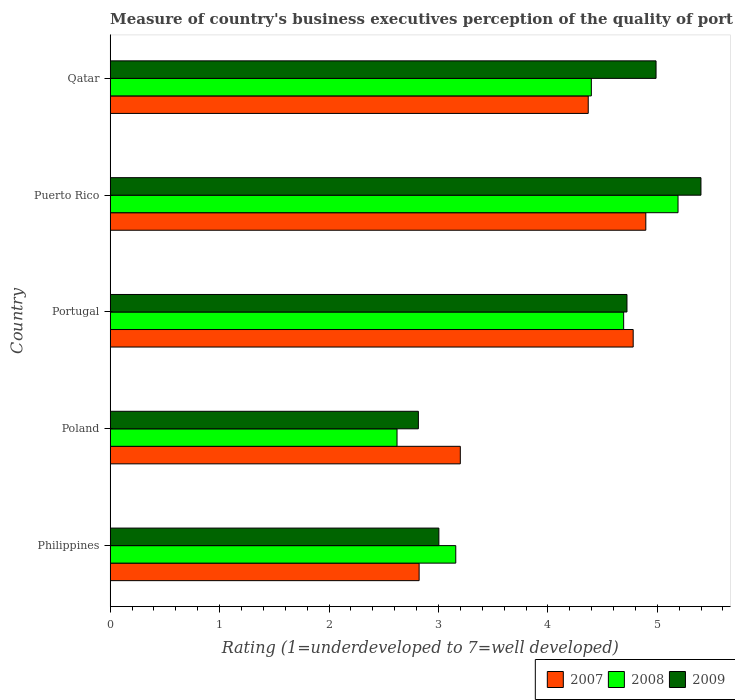How many groups of bars are there?
Your answer should be very brief. 5. How many bars are there on the 5th tick from the bottom?
Keep it short and to the point. 3. In how many cases, is the number of bars for a given country not equal to the number of legend labels?
Make the answer very short. 0. What is the ratings of the quality of port infrastructure in 2007 in Portugal?
Offer a terse response. 4.78. Across all countries, what is the maximum ratings of the quality of port infrastructure in 2007?
Provide a succinct answer. 4.89. Across all countries, what is the minimum ratings of the quality of port infrastructure in 2008?
Make the answer very short. 2.62. In which country was the ratings of the quality of port infrastructure in 2008 maximum?
Your answer should be compact. Puerto Rico. In which country was the ratings of the quality of port infrastructure in 2007 minimum?
Provide a succinct answer. Philippines. What is the total ratings of the quality of port infrastructure in 2008 in the graph?
Provide a short and direct response. 20.06. What is the difference between the ratings of the quality of port infrastructure in 2009 in Portugal and that in Puerto Rico?
Give a very brief answer. -0.68. What is the difference between the ratings of the quality of port infrastructure in 2008 in Philippines and the ratings of the quality of port infrastructure in 2009 in Portugal?
Provide a succinct answer. -1.56. What is the average ratings of the quality of port infrastructure in 2007 per country?
Keep it short and to the point. 4.01. What is the difference between the ratings of the quality of port infrastructure in 2009 and ratings of the quality of port infrastructure in 2008 in Portugal?
Provide a short and direct response. 0.03. In how many countries, is the ratings of the quality of port infrastructure in 2009 greater than 3 ?
Your answer should be very brief. 4. What is the ratio of the ratings of the quality of port infrastructure in 2007 in Philippines to that in Puerto Rico?
Give a very brief answer. 0.58. What is the difference between the highest and the second highest ratings of the quality of port infrastructure in 2007?
Your response must be concise. 0.12. What is the difference between the highest and the lowest ratings of the quality of port infrastructure in 2009?
Your answer should be compact. 2.58. Is the sum of the ratings of the quality of port infrastructure in 2009 in Poland and Puerto Rico greater than the maximum ratings of the quality of port infrastructure in 2008 across all countries?
Provide a succinct answer. Yes. What does the 3rd bar from the bottom in Qatar represents?
Provide a short and direct response. 2009. How many countries are there in the graph?
Offer a terse response. 5. Are the values on the major ticks of X-axis written in scientific E-notation?
Your response must be concise. No. Does the graph contain any zero values?
Keep it short and to the point. No. Where does the legend appear in the graph?
Your answer should be compact. Bottom right. How many legend labels are there?
Your response must be concise. 3. What is the title of the graph?
Give a very brief answer. Measure of country's business executives perception of the quality of port infrastructure. Does "2011" appear as one of the legend labels in the graph?
Ensure brevity in your answer.  No. What is the label or title of the X-axis?
Ensure brevity in your answer.  Rating (1=underdeveloped to 7=well developed). What is the Rating (1=underdeveloped to 7=well developed) of 2007 in Philippines?
Offer a very short reply. 2.82. What is the Rating (1=underdeveloped to 7=well developed) of 2008 in Philippines?
Give a very brief answer. 3.16. What is the Rating (1=underdeveloped to 7=well developed) of 2009 in Philippines?
Offer a terse response. 3. What is the Rating (1=underdeveloped to 7=well developed) of 2007 in Poland?
Your response must be concise. 3.2. What is the Rating (1=underdeveloped to 7=well developed) in 2008 in Poland?
Your response must be concise. 2.62. What is the Rating (1=underdeveloped to 7=well developed) of 2009 in Poland?
Keep it short and to the point. 2.82. What is the Rating (1=underdeveloped to 7=well developed) in 2007 in Portugal?
Ensure brevity in your answer.  4.78. What is the Rating (1=underdeveloped to 7=well developed) in 2008 in Portugal?
Your response must be concise. 4.69. What is the Rating (1=underdeveloped to 7=well developed) of 2009 in Portugal?
Your answer should be very brief. 4.72. What is the Rating (1=underdeveloped to 7=well developed) of 2007 in Puerto Rico?
Provide a succinct answer. 4.89. What is the Rating (1=underdeveloped to 7=well developed) of 2008 in Puerto Rico?
Make the answer very short. 5.19. What is the Rating (1=underdeveloped to 7=well developed) in 2009 in Puerto Rico?
Make the answer very short. 5.4. What is the Rating (1=underdeveloped to 7=well developed) of 2007 in Qatar?
Give a very brief answer. 4.37. What is the Rating (1=underdeveloped to 7=well developed) of 2008 in Qatar?
Provide a succinct answer. 4.4. What is the Rating (1=underdeveloped to 7=well developed) in 2009 in Qatar?
Provide a succinct answer. 4.99. Across all countries, what is the maximum Rating (1=underdeveloped to 7=well developed) of 2007?
Ensure brevity in your answer.  4.89. Across all countries, what is the maximum Rating (1=underdeveloped to 7=well developed) in 2008?
Your answer should be very brief. 5.19. Across all countries, what is the maximum Rating (1=underdeveloped to 7=well developed) of 2009?
Make the answer very short. 5.4. Across all countries, what is the minimum Rating (1=underdeveloped to 7=well developed) of 2007?
Keep it short and to the point. 2.82. Across all countries, what is the minimum Rating (1=underdeveloped to 7=well developed) in 2008?
Provide a succinct answer. 2.62. Across all countries, what is the minimum Rating (1=underdeveloped to 7=well developed) in 2009?
Give a very brief answer. 2.82. What is the total Rating (1=underdeveloped to 7=well developed) in 2007 in the graph?
Your answer should be compact. 20.07. What is the total Rating (1=underdeveloped to 7=well developed) in 2008 in the graph?
Provide a succinct answer. 20.06. What is the total Rating (1=underdeveloped to 7=well developed) in 2009 in the graph?
Offer a terse response. 20.93. What is the difference between the Rating (1=underdeveloped to 7=well developed) in 2007 in Philippines and that in Poland?
Provide a short and direct response. -0.38. What is the difference between the Rating (1=underdeveloped to 7=well developed) of 2008 in Philippines and that in Poland?
Your answer should be very brief. 0.54. What is the difference between the Rating (1=underdeveloped to 7=well developed) in 2009 in Philippines and that in Poland?
Your answer should be very brief. 0.19. What is the difference between the Rating (1=underdeveloped to 7=well developed) in 2007 in Philippines and that in Portugal?
Ensure brevity in your answer.  -1.96. What is the difference between the Rating (1=underdeveloped to 7=well developed) of 2008 in Philippines and that in Portugal?
Provide a short and direct response. -1.53. What is the difference between the Rating (1=underdeveloped to 7=well developed) in 2009 in Philippines and that in Portugal?
Offer a very short reply. -1.72. What is the difference between the Rating (1=underdeveloped to 7=well developed) of 2007 in Philippines and that in Puerto Rico?
Your answer should be very brief. -2.07. What is the difference between the Rating (1=underdeveloped to 7=well developed) in 2008 in Philippines and that in Puerto Rico?
Your answer should be compact. -2.03. What is the difference between the Rating (1=underdeveloped to 7=well developed) of 2009 in Philippines and that in Puerto Rico?
Your response must be concise. -2.39. What is the difference between the Rating (1=underdeveloped to 7=well developed) of 2007 in Philippines and that in Qatar?
Offer a terse response. -1.55. What is the difference between the Rating (1=underdeveloped to 7=well developed) of 2008 in Philippines and that in Qatar?
Your response must be concise. -1.24. What is the difference between the Rating (1=underdeveloped to 7=well developed) of 2009 in Philippines and that in Qatar?
Give a very brief answer. -1.98. What is the difference between the Rating (1=underdeveloped to 7=well developed) of 2007 in Poland and that in Portugal?
Keep it short and to the point. -1.58. What is the difference between the Rating (1=underdeveloped to 7=well developed) in 2008 in Poland and that in Portugal?
Offer a terse response. -2.07. What is the difference between the Rating (1=underdeveloped to 7=well developed) in 2009 in Poland and that in Portugal?
Make the answer very short. -1.91. What is the difference between the Rating (1=underdeveloped to 7=well developed) of 2007 in Poland and that in Puerto Rico?
Your answer should be compact. -1.7. What is the difference between the Rating (1=underdeveloped to 7=well developed) in 2008 in Poland and that in Puerto Rico?
Ensure brevity in your answer.  -2.57. What is the difference between the Rating (1=underdeveloped to 7=well developed) of 2009 in Poland and that in Puerto Rico?
Your answer should be very brief. -2.58. What is the difference between the Rating (1=underdeveloped to 7=well developed) in 2007 in Poland and that in Qatar?
Your answer should be compact. -1.17. What is the difference between the Rating (1=underdeveloped to 7=well developed) in 2008 in Poland and that in Qatar?
Provide a short and direct response. -1.78. What is the difference between the Rating (1=underdeveloped to 7=well developed) in 2009 in Poland and that in Qatar?
Offer a terse response. -2.17. What is the difference between the Rating (1=underdeveloped to 7=well developed) in 2007 in Portugal and that in Puerto Rico?
Your response must be concise. -0.12. What is the difference between the Rating (1=underdeveloped to 7=well developed) of 2008 in Portugal and that in Puerto Rico?
Offer a very short reply. -0.5. What is the difference between the Rating (1=underdeveloped to 7=well developed) in 2009 in Portugal and that in Puerto Rico?
Offer a terse response. -0.68. What is the difference between the Rating (1=underdeveloped to 7=well developed) of 2007 in Portugal and that in Qatar?
Keep it short and to the point. 0.41. What is the difference between the Rating (1=underdeveloped to 7=well developed) in 2008 in Portugal and that in Qatar?
Keep it short and to the point. 0.3. What is the difference between the Rating (1=underdeveloped to 7=well developed) of 2009 in Portugal and that in Qatar?
Provide a succinct answer. -0.27. What is the difference between the Rating (1=underdeveloped to 7=well developed) of 2007 in Puerto Rico and that in Qatar?
Ensure brevity in your answer.  0.53. What is the difference between the Rating (1=underdeveloped to 7=well developed) in 2008 in Puerto Rico and that in Qatar?
Offer a very short reply. 0.79. What is the difference between the Rating (1=underdeveloped to 7=well developed) in 2009 in Puerto Rico and that in Qatar?
Provide a succinct answer. 0.41. What is the difference between the Rating (1=underdeveloped to 7=well developed) in 2007 in Philippines and the Rating (1=underdeveloped to 7=well developed) in 2008 in Poland?
Give a very brief answer. 0.2. What is the difference between the Rating (1=underdeveloped to 7=well developed) in 2007 in Philippines and the Rating (1=underdeveloped to 7=well developed) in 2009 in Poland?
Provide a short and direct response. 0.01. What is the difference between the Rating (1=underdeveloped to 7=well developed) of 2008 in Philippines and the Rating (1=underdeveloped to 7=well developed) of 2009 in Poland?
Offer a very short reply. 0.34. What is the difference between the Rating (1=underdeveloped to 7=well developed) in 2007 in Philippines and the Rating (1=underdeveloped to 7=well developed) in 2008 in Portugal?
Give a very brief answer. -1.87. What is the difference between the Rating (1=underdeveloped to 7=well developed) of 2007 in Philippines and the Rating (1=underdeveloped to 7=well developed) of 2009 in Portugal?
Ensure brevity in your answer.  -1.9. What is the difference between the Rating (1=underdeveloped to 7=well developed) of 2008 in Philippines and the Rating (1=underdeveloped to 7=well developed) of 2009 in Portugal?
Offer a terse response. -1.56. What is the difference between the Rating (1=underdeveloped to 7=well developed) in 2007 in Philippines and the Rating (1=underdeveloped to 7=well developed) in 2008 in Puerto Rico?
Ensure brevity in your answer.  -2.37. What is the difference between the Rating (1=underdeveloped to 7=well developed) of 2007 in Philippines and the Rating (1=underdeveloped to 7=well developed) of 2009 in Puerto Rico?
Your answer should be very brief. -2.58. What is the difference between the Rating (1=underdeveloped to 7=well developed) of 2008 in Philippines and the Rating (1=underdeveloped to 7=well developed) of 2009 in Puerto Rico?
Make the answer very short. -2.24. What is the difference between the Rating (1=underdeveloped to 7=well developed) in 2007 in Philippines and the Rating (1=underdeveloped to 7=well developed) in 2008 in Qatar?
Your answer should be very brief. -1.57. What is the difference between the Rating (1=underdeveloped to 7=well developed) in 2007 in Philippines and the Rating (1=underdeveloped to 7=well developed) in 2009 in Qatar?
Provide a short and direct response. -2.16. What is the difference between the Rating (1=underdeveloped to 7=well developed) in 2008 in Philippines and the Rating (1=underdeveloped to 7=well developed) in 2009 in Qatar?
Keep it short and to the point. -1.83. What is the difference between the Rating (1=underdeveloped to 7=well developed) of 2007 in Poland and the Rating (1=underdeveloped to 7=well developed) of 2008 in Portugal?
Provide a succinct answer. -1.49. What is the difference between the Rating (1=underdeveloped to 7=well developed) in 2007 in Poland and the Rating (1=underdeveloped to 7=well developed) in 2009 in Portugal?
Provide a succinct answer. -1.52. What is the difference between the Rating (1=underdeveloped to 7=well developed) in 2008 in Poland and the Rating (1=underdeveloped to 7=well developed) in 2009 in Portugal?
Keep it short and to the point. -2.1. What is the difference between the Rating (1=underdeveloped to 7=well developed) of 2007 in Poland and the Rating (1=underdeveloped to 7=well developed) of 2008 in Puerto Rico?
Ensure brevity in your answer.  -1.99. What is the difference between the Rating (1=underdeveloped to 7=well developed) in 2007 in Poland and the Rating (1=underdeveloped to 7=well developed) in 2009 in Puerto Rico?
Your answer should be very brief. -2.2. What is the difference between the Rating (1=underdeveloped to 7=well developed) of 2008 in Poland and the Rating (1=underdeveloped to 7=well developed) of 2009 in Puerto Rico?
Give a very brief answer. -2.78. What is the difference between the Rating (1=underdeveloped to 7=well developed) of 2007 in Poland and the Rating (1=underdeveloped to 7=well developed) of 2008 in Qatar?
Make the answer very short. -1.2. What is the difference between the Rating (1=underdeveloped to 7=well developed) in 2007 in Poland and the Rating (1=underdeveloped to 7=well developed) in 2009 in Qatar?
Your response must be concise. -1.79. What is the difference between the Rating (1=underdeveloped to 7=well developed) in 2008 in Poland and the Rating (1=underdeveloped to 7=well developed) in 2009 in Qatar?
Keep it short and to the point. -2.37. What is the difference between the Rating (1=underdeveloped to 7=well developed) of 2007 in Portugal and the Rating (1=underdeveloped to 7=well developed) of 2008 in Puerto Rico?
Provide a short and direct response. -0.41. What is the difference between the Rating (1=underdeveloped to 7=well developed) of 2007 in Portugal and the Rating (1=underdeveloped to 7=well developed) of 2009 in Puerto Rico?
Ensure brevity in your answer.  -0.62. What is the difference between the Rating (1=underdeveloped to 7=well developed) of 2008 in Portugal and the Rating (1=underdeveloped to 7=well developed) of 2009 in Puerto Rico?
Your response must be concise. -0.71. What is the difference between the Rating (1=underdeveloped to 7=well developed) of 2007 in Portugal and the Rating (1=underdeveloped to 7=well developed) of 2008 in Qatar?
Your response must be concise. 0.38. What is the difference between the Rating (1=underdeveloped to 7=well developed) of 2007 in Portugal and the Rating (1=underdeveloped to 7=well developed) of 2009 in Qatar?
Provide a succinct answer. -0.21. What is the difference between the Rating (1=underdeveloped to 7=well developed) in 2008 in Portugal and the Rating (1=underdeveloped to 7=well developed) in 2009 in Qatar?
Keep it short and to the point. -0.3. What is the difference between the Rating (1=underdeveloped to 7=well developed) of 2007 in Puerto Rico and the Rating (1=underdeveloped to 7=well developed) of 2008 in Qatar?
Offer a terse response. 0.5. What is the difference between the Rating (1=underdeveloped to 7=well developed) in 2007 in Puerto Rico and the Rating (1=underdeveloped to 7=well developed) in 2009 in Qatar?
Give a very brief answer. -0.09. What is the difference between the Rating (1=underdeveloped to 7=well developed) of 2008 in Puerto Rico and the Rating (1=underdeveloped to 7=well developed) of 2009 in Qatar?
Ensure brevity in your answer.  0.2. What is the average Rating (1=underdeveloped to 7=well developed) in 2007 per country?
Ensure brevity in your answer.  4.01. What is the average Rating (1=underdeveloped to 7=well developed) in 2008 per country?
Provide a short and direct response. 4.01. What is the average Rating (1=underdeveloped to 7=well developed) in 2009 per country?
Keep it short and to the point. 4.19. What is the difference between the Rating (1=underdeveloped to 7=well developed) of 2007 and Rating (1=underdeveloped to 7=well developed) of 2008 in Philippines?
Keep it short and to the point. -0.33. What is the difference between the Rating (1=underdeveloped to 7=well developed) of 2007 and Rating (1=underdeveloped to 7=well developed) of 2009 in Philippines?
Offer a terse response. -0.18. What is the difference between the Rating (1=underdeveloped to 7=well developed) of 2008 and Rating (1=underdeveloped to 7=well developed) of 2009 in Philippines?
Keep it short and to the point. 0.15. What is the difference between the Rating (1=underdeveloped to 7=well developed) in 2007 and Rating (1=underdeveloped to 7=well developed) in 2008 in Poland?
Offer a very short reply. 0.58. What is the difference between the Rating (1=underdeveloped to 7=well developed) in 2007 and Rating (1=underdeveloped to 7=well developed) in 2009 in Poland?
Give a very brief answer. 0.38. What is the difference between the Rating (1=underdeveloped to 7=well developed) of 2008 and Rating (1=underdeveloped to 7=well developed) of 2009 in Poland?
Provide a short and direct response. -0.2. What is the difference between the Rating (1=underdeveloped to 7=well developed) of 2007 and Rating (1=underdeveloped to 7=well developed) of 2008 in Portugal?
Provide a short and direct response. 0.09. What is the difference between the Rating (1=underdeveloped to 7=well developed) of 2007 and Rating (1=underdeveloped to 7=well developed) of 2009 in Portugal?
Provide a succinct answer. 0.06. What is the difference between the Rating (1=underdeveloped to 7=well developed) of 2008 and Rating (1=underdeveloped to 7=well developed) of 2009 in Portugal?
Your answer should be compact. -0.03. What is the difference between the Rating (1=underdeveloped to 7=well developed) in 2007 and Rating (1=underdeveloped to 7=well developed) in 2008 in Puerto Rico?
Offer a very short reply. -0.29. What is the difference between the Rating (1=underdeveloped to 7=well developed) in 2007 and Rating (1=underdeveloped to 7=well developed) in 2009 in Puerto Rico?
Your response must be concise. -0.5. What is the difference between the Rating (1=underdeveloped to 7=well developed) in 2008 and Rating (1=underdeveloped to 7=well developed) in 2009 in Puerto Rico?
Ensure brevity in your answer.  -0.21. What is the difference between the Rating (1=underdeveloped to 7=well developed) of 2007 and Rating (1=underdeveloped to 7=well developed) of 2008 in Qatar?
Keep it short and to the point. -0.03. What is the difference between the Rating (1=underdeveloped to 7=well developed) in 2007 and Rating (1=underdeveloped to 7=well developed) in 2009 in Qatar?
Your answer should be very brief. -0.62. What is the difference between the Rating (1=underdeveloped to 7=well developed) of 2008 and Rating (1=underdeveloped to 7=well developed) of 2009 in Qatar?
Your answer should be compact. -0.59. What is the ratio of the Rating (1=underdeveloped to 7=well developed) of 2007 in Philippines to that in Poland?
Offer a very short reply. 0.88. What is the ratio of the Rating (1=underdeveloped to 7=well developed) in 2008 in Philippines to that in Poland?
Keep it short and to the point. 1.2. What is the ratio of the Rating (1=underdeveloped to 7=well developed) of 2009 in Philippines to that in Poland?
Ensure brevity in your answer.  1.07. What is the ratio of the Rating (1=underdeveloped to 7=well developed) of 2007 in Philippines to that in Portugal?
Offer a very short reply. 0.59. What is the ratio of the Rating (1=underdeveloped to 7=well developed) in 2008 in Philippines to that in Portugal?
Provide a short and direct response. 0.67. What is the ratio of the Rating (1=underdeveloped to 7=well developed) in 2009 in Philippines to that in Portugal?
Your answer should be compact. 0.64. What is the ratio of the Rating (1=underdeveloped to 7=well developed) of 2007 in Philippines to that in Puerto Rico?
Keep it short and to the point. 0.58. What is the ratio of the Rating (1=underdeveloped to 7=well developed) of 2008 in Philippines to that in Puerto Rico?
Keep it short and to the point. 0.61. What is the ratio of the Rating (1=underdeveloped to 7=well developed) of 2009 in Philippines to that in Puerto Rico?
Provide a short and direct response. 0.56. What is the ratio of the Rating (1=underdeveloped to 7=well developed) of 2007 in Philippines to that in Qatar?
Provide a short and direct response. 0.65. What is the ratio of the Rating (1=underdeveloped to 7=well developed) of 2008 in Philippines to that in Qatar?
Provide a short and direct response. 0.72. What is the ratio of the Rating (1=underdeveloped to 7=well developed) of 2009 in Philippines to that in Qatar?
Your answer should be very brief. 0.6. What is the ratio of the Rating (1=underdeveloped to 7=well developed) of 2007 in Poland to that in Portugal?
Provide a short and direct response. 0.67. What is the ratio of the Rating (1=underdeveloped to 7=well developed) in 2008 in Poland to that in Portugal?
Provide a succinct answer. 0.56. What is the ratio of the Rating (1=underdeveloped to 7=well developed) of 2009 in Poland to that in Portugal?
Your answer should be very brief. 0.6. What is the ratio of the Rating (1=underdeveloped to 7=well developed) of 2007 in Poland to that in Puerto Rico?
Your answer should be compact. 0.65. What is the ratio of the Rating (1=underdeveloped to 7=well developed) of 2008 in Poland to that in Puerto Rico?
Give a very brief answer. 0.51. What is the ratio of the Rating (1=underdeveloped to 7=well developed) in 2009 in Poland to that in Puerto Rico?
Your response must be concise. 0.52. What is the ratio of the Rating (1=underdeveloped to 7=well developed) of 2007 in Poland to that in Qatar?
Provide a short and direct response. 0.73. What is the ratio of the Rating (1=underdeveloped to 7=well developed) of 2008 in Poland to that in Qatar?
Offer a very short reply. 0.6. What is the ratio of the Rating (1=underdeveloped to 7=well developed) of 2009 in Poland to that in Qatar?
Ensure brevity in your answer.  0.56. What is the ratio of the Rating (1=underdeveloped to 7=well developed) of 2007 in Portugal to that in Puerto Rico?
Make the answer very short. 0.98. What is the ratio of the Rating (1=underdeveloped to 7=well developed) of 2008 in Portugal to that in Puerto Rico?
Offer a terse response. 0.9. What is the ratio of the Rating (1=underdeveloped to 7=well developed) of 2009 in Portugal to that in Puerto Rico?
Offer a very short reply. 0.87. What is the ratio of the Rating (1=underdeveloped to 7=well developed) in 2007 in Portugal to that in Qatar?
Offer a very short reply. 1.09. What is the ratio of the Rating (1=underdeveloped to 7=well developed) in 2008 in Portugal to that in Qatar?
Give a very brief answer. 1.07. What is the ratio of the Rating (1=underdeveloped to 7=well developed) in 2009 in Portugal to that in Qatar?
Offer a terse response. 0.95. What is the ratio of the Rating (1=underdeveloped to 7=well developed) of 2007 in Puerto Rico to that in Qatar?
Your answer should be compact. 1.12. What is the ratio of the Rating (1=underdeveloped to 7=well developed) of 2008 in Puerto Rico to that in Qatar?
Provide a succinct answer. 1.18. What is the ratio of the Rating (1=underdeveloped to 7=well developed) in 2009 in Puerto Rico to that in Qatar?
Provide a short and direct response. 1.08. What is the difference between the highest and the second highest Rating (1=underdeveloped to 7=well developed) in 2007?
Give a very brief answer. 0.12. What is the difference between the highest and the second highest Rating (1=underdeveloped to 7=well developed) in 2008?
Your response must be concise. 0.5. What is the difference between the highest and the second highest Rating (1=underdeveloped to 7=well developed) of 2009?
Offer a very short reply. 0.41. What is the difference between the highest and the lowest Rating (1=underdeveloped to 7=well developed) in 2007?
Provide a succinct answer. 2.07. What is the difference between the highest and the lowest Rating (1=underdeveloped to 7=well developed) in 2008?
Offer a terse response. 2.57. What is the difference between the highest and the lowest Rating (1=underdeveloped to 7=well developed) in 2009?
Your answer should be compact. 2.58. 